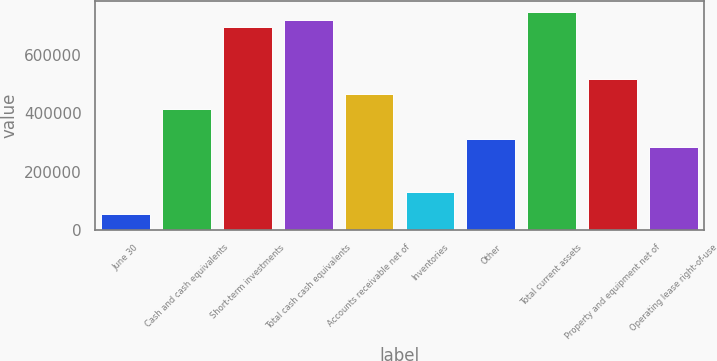<chart> <loc_0><loc_0><loc_500><loc_500><bar_chart><fcel>June 30<fcel>Cash and cash equivalents<fcel>Short-term investments<fcel>Total cash cash equivalents<fcel>Accounts receivable net of<fcel>Inventories<fcel>Other<fcel>Total current assets<fcel>Property and equipment net of<fcel>Operating lease right-of-use<nl><fcel>52202.4<fcel>413832<fcel>697970<fcel>723801<fcel>465494<fcel>129694<fcel>310509<fcel>749631<fcel>517155<fcel>284679<nl></chart> 